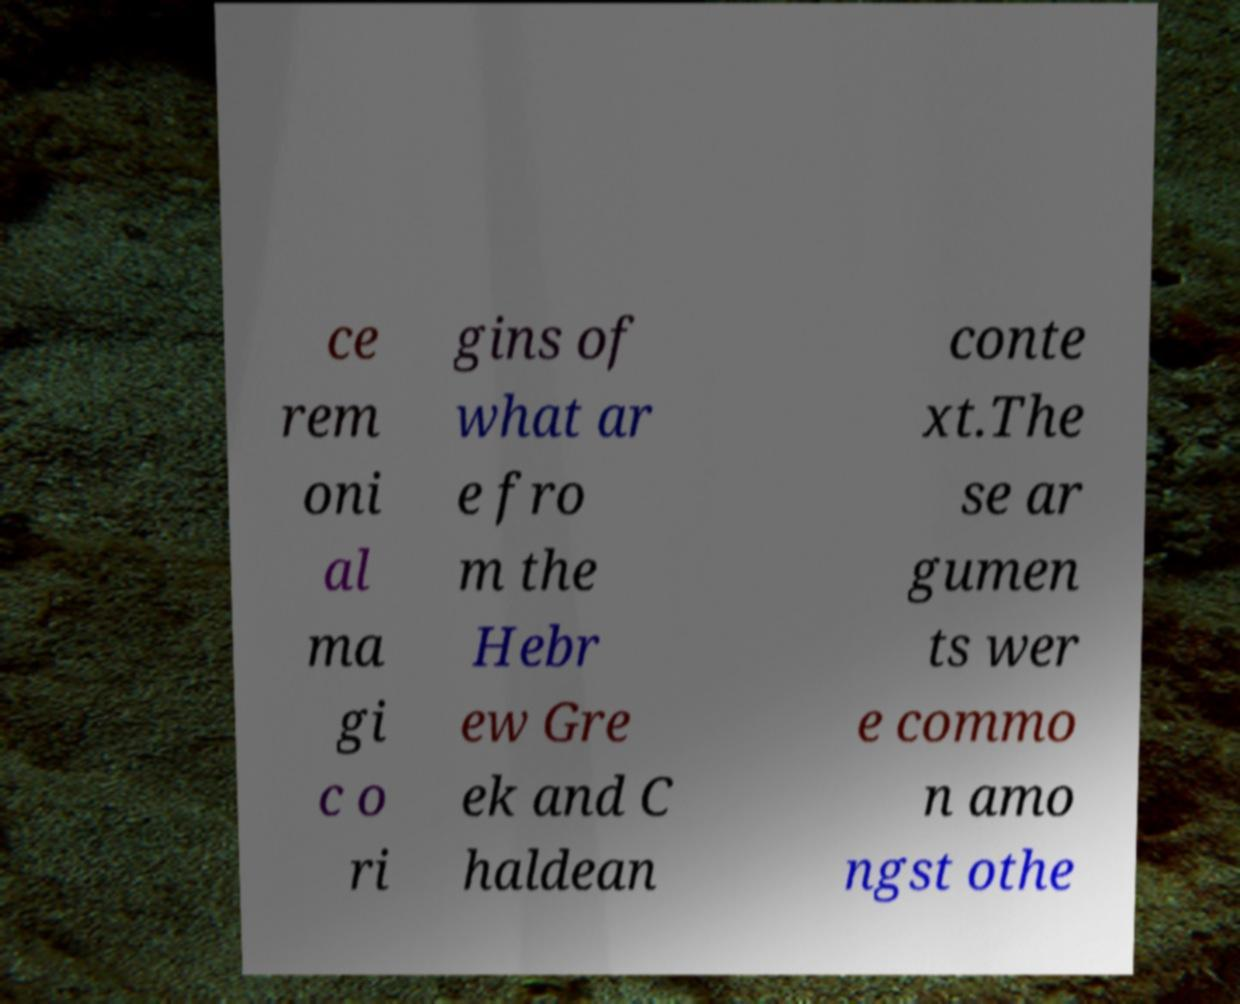For documentation purposes, I need the text within this image transcribed. Could you provide that? ce rem oni al ma gi c o ri gins of what ar e fro m the Hebr ew Gre ek and C haldean conte xt.The se ar gumen ts wer e commo n amo ngst othe 